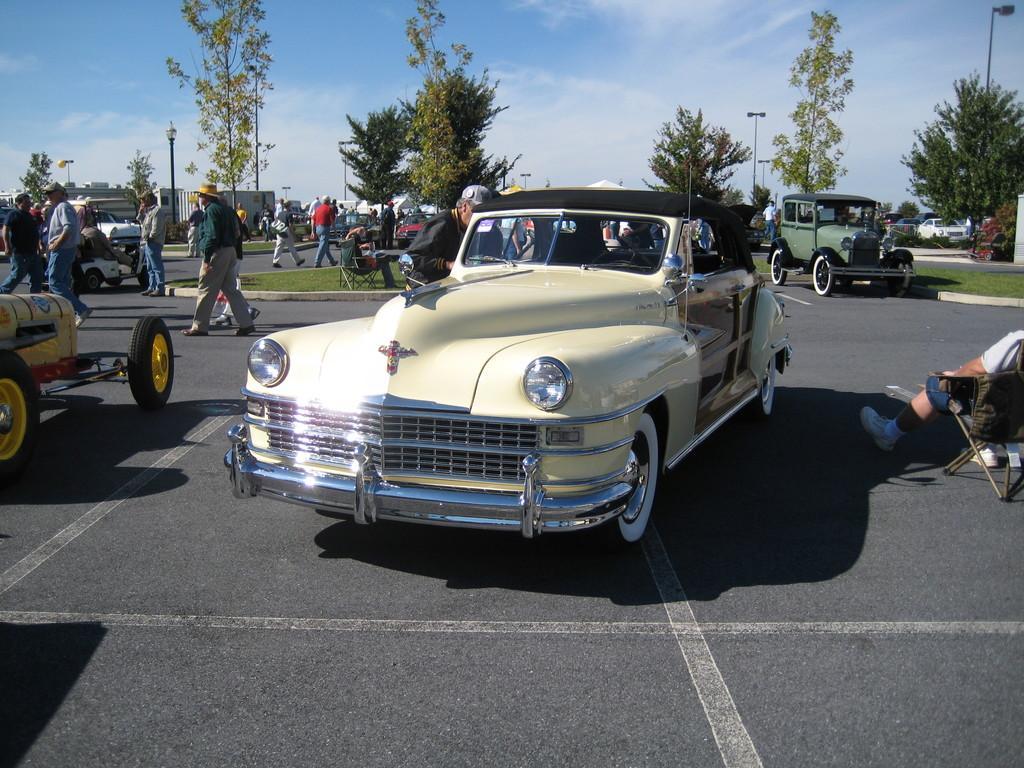Can you describe this image briefly? In this picture I can observe some cars on the road. There are few people walking on the road. In the background there are trees and sky. 